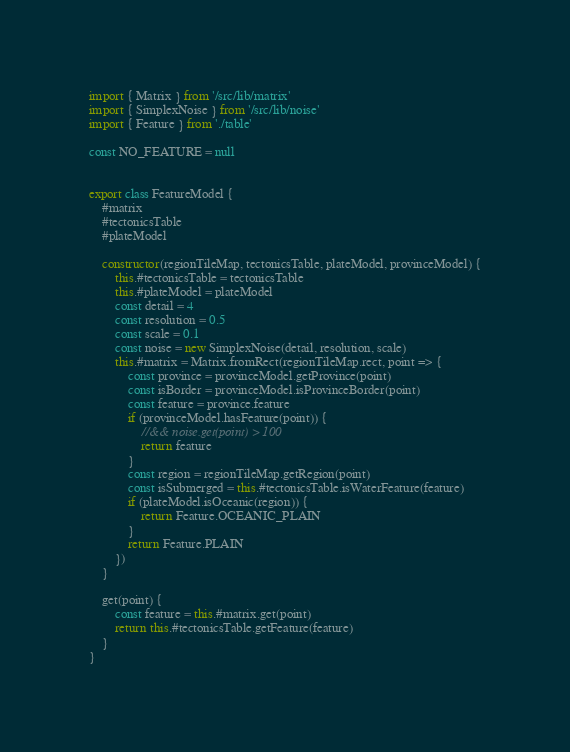<code> <loc_0><loc_0><loc_500><loc_500><_JavaScript_>import { Matrix } from '/src/lib/matrix'
import { SimplexNoise } from '/src/lib/noise'
import { Feature } from './table'

const NO_FEATURE = null


export class FeatureModel {
    #matrix
    #tectonicsTable
    #plateModel

    constructor(regionTileMap, tectonicsTable, plateModel, provinceModel) {
        this.#tectonicsTable = tectonicsTable
        this.#plateModel = plateModel
        const detail = 4
        const resolution = 0.5
        const scale = 0.1
        const noise = new SimplexNoise(detail, resolution, scale)
        this.#matrix = Matrix.fromRect(regionTileMap.rect, point => {
            const province = provinceModel.getProvince(point)
            const isBorder = provinceModel.isProvinceBorder(point)
            const feature = province.feature
            if (provinceModel.hasFeature(point)) {
                //&& noise.get(point) > 100
                return feature
            }
            const region = regionTileMap.getRegion(point)
            const isSubmerged = this.#tectonicsTable.isWaterFeature(feature)
            if (plateModel.isOceanic(region)) {
                return Feature.OCEANIC_PLAIN
            }
            return Feature.PLAIN
        })
    }

    get(point) {
        const feature = this.#matrix.get(point)
        return this.#tectonicsTable.getFeature(feature)
    }
}
</code> 